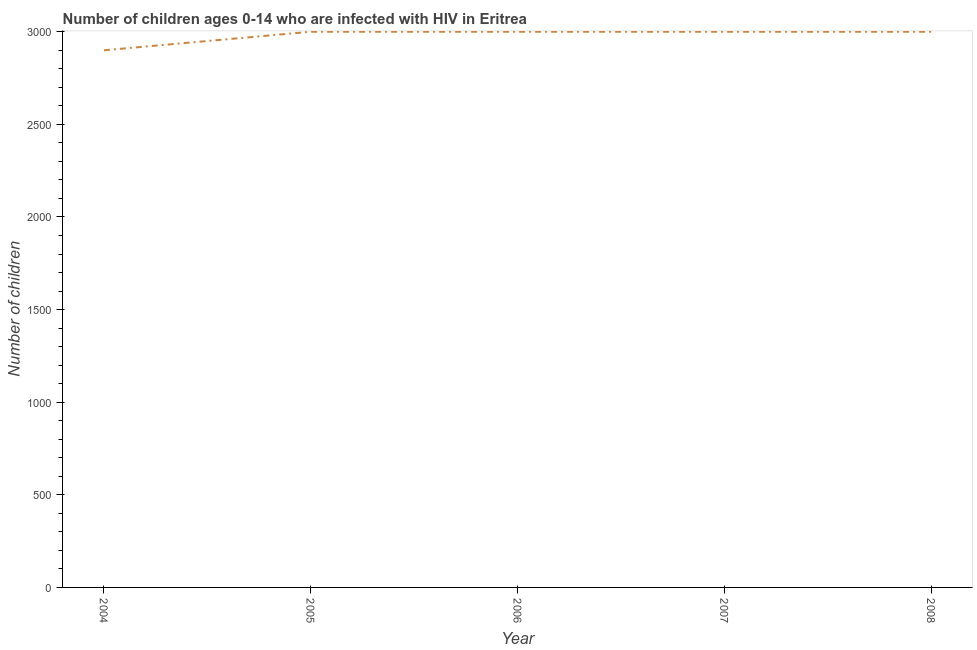What is the number of children living with hiv in 2006?
Keep it short and to the point. 3000. Across all years, what is the maximum number of children living with hiv?
Your answer should be compact. 3000. Across all years, what is the minimum number of children living with hiv?
Keep it short and to the point. 2900. In which year was the number of children living with hiv maximum?
Keep it short and to the point. 2005. In which year was the number of children living with hiv minimum?
Make the answer very short. 2004. What is the sum of the number of children living with hiv?
Ensure brevity in your answer.  1.49e+04. What is the average number of children living with hiv per year?
Ensure brevity in your answer.  2980. What is the median number of children living with hiv?
Keep it short and to the point. 3000. What is the ratio of the number of children living with hiv in 2006 to that in 2007?
Make the answer very short. 1. Is the difference between the number of children living with hiv in 2007 and 2008 greater than the difference between any two years?
Keep it short and to the point. No. What is the difference between the highest and the second highest number of children living with hiv?
Offer a very short reply. 0. Is the sum of the number of children living with hiv in 2004 and 2007 greater than the maximum number of children living with hiv across all years?
Make the answer very short. Yes. What is the difference between the highest and the lowest number of children living with hiv?
Your answer should be very brief. 100. In how many years, is the number of children living with hiv greater than the average number of children living with hiv taken over all years?
Keep it short and to the point. 4. Does the number of children living with hiv monotonically increase over the years?
Your response must be concise. No. How many lines are there?
Your response must be concise. 1. What is the difference between two consecutive major ticks on the Y-axis?
Give a very brief answer. 500. Are the values on the major ticks of Y-axis written in scientific E-notation?
Provide a succinct answer. No. Does the graph contain grids?
Offer a terse response. No. What is the title of the graph?
Keep it short and to the point. Number of children ages 0-14 who are infected with HIV in Eritrea. What is the label or title of the X-axis?
Ensure brevity in your answer.  Year. What is the label or title of the Y-axis?
Your response must be concise. Number of children. What is the Number of children of 2004?
Keep it short and to the point. 2900. What is the Number of children in 2005?
Your response must be concise. 3000. What is the Number of children of 2006?
Make the answer very short. 3000. What is the Number of children in 2007?
Ensure brevity in your answer.  3000. What is the Number of children of 2008?
Your answer should be very brief. 3000. What is the difference between the Number of children in 2004 and 2005?
Give a very brief answer. -100. What is the difference between the Number of children in 2004 and 2006?
Give a very brief answer. -100. What is the difference between the Number of children in 2004 and 2007?
Your response must be concise. -100. What is the difference between the Number of children in 2004 and 2008?
Ensure brevity in your answer.  -100. What is the difference between the Number of children in 2005 and 2008?
Make the answer very short. 0. What is the difference between the Number of children in 2006 and 2007?
Your answer should be very brief. 0. What is the difference between the Number of children in 2007 and 2008?
Ensure brevity in your answer.  0. What is the ratio of the Number of children in 2006 to that in 2007?
Provide a succinct answer. 1. What is the ratio of the Number of children in 2006 to that in 2008?
Your answer should be very brief. 1. 